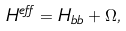Convert formula to latex. <formula><loc_0><loc_0><loc_500><loc_500>H ^ { e f f } = H _ { b b } + \Omega ,</formula> 